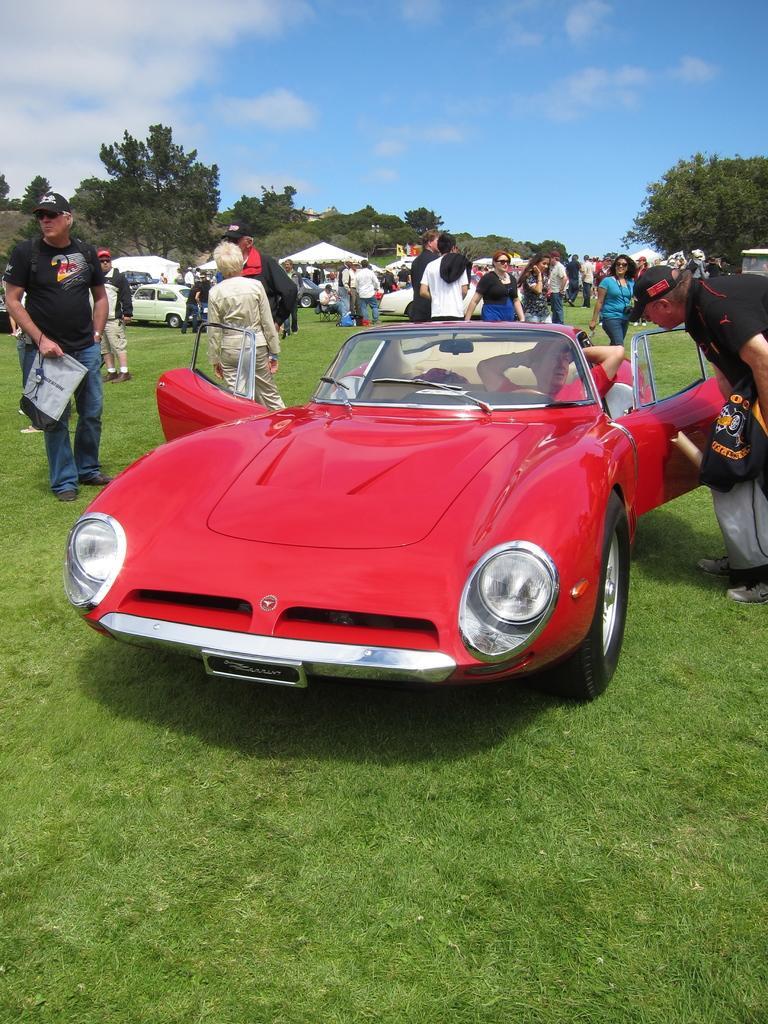Can you describe this image briefly? There is a car and humans on the ground near trees and mountains. 